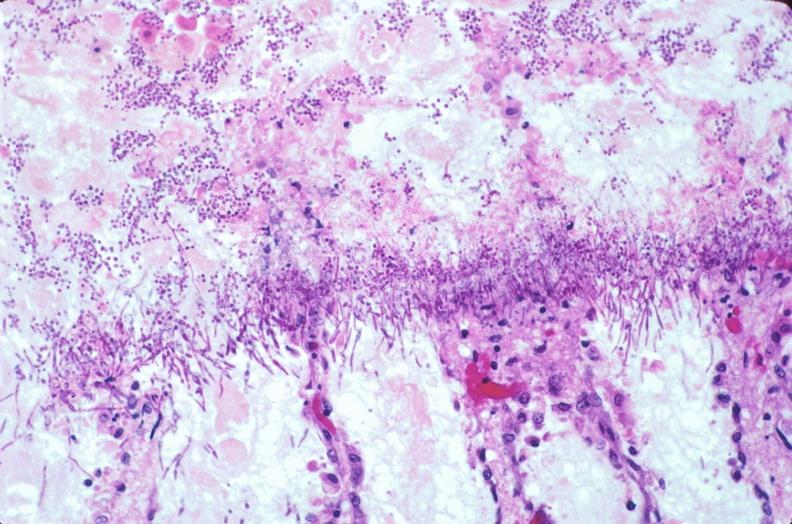does antitrypsin show duodenum, necrotizing enteritis with pseudomembrane, candida?
Answer the question using a single word or phrase. No 